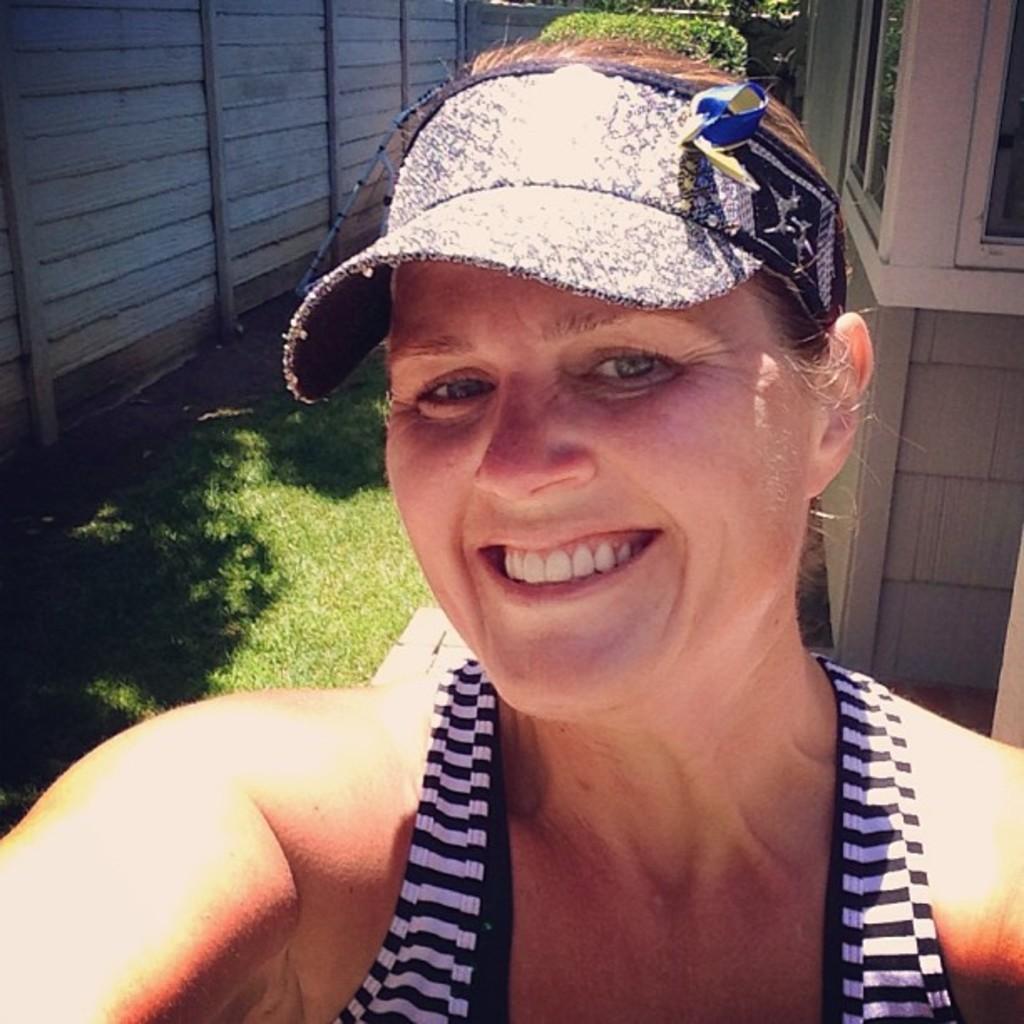Could you give a brief overview of what you see in this image? In this image there is a woman with a smile on her face, behind the woman there is grass on the surface and there is a wooden fence. 